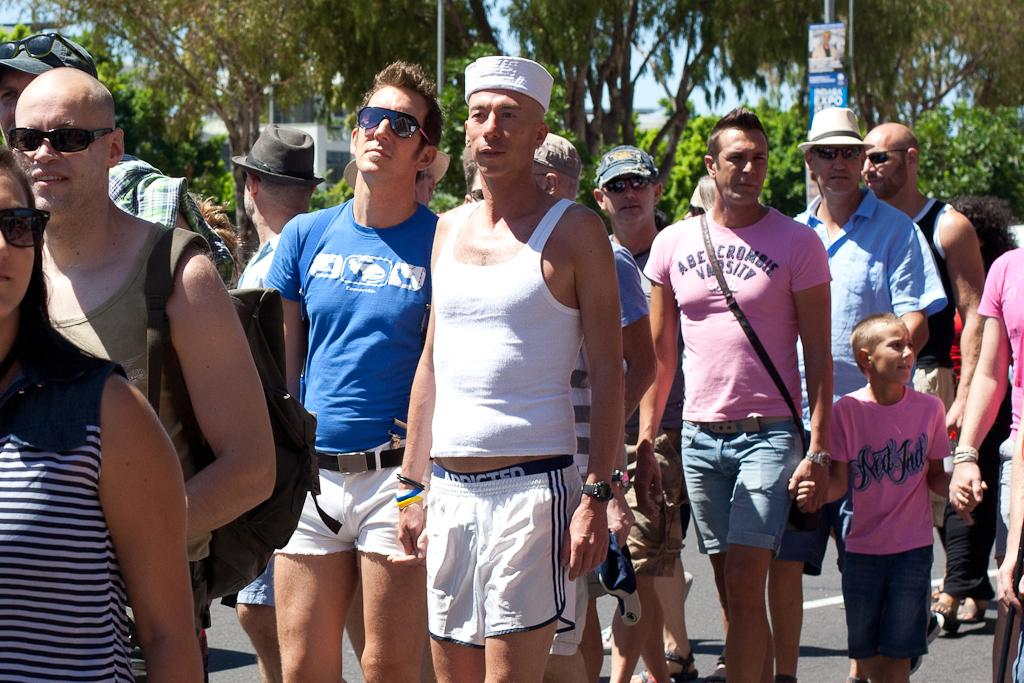Provide a one-sentence caption for the provided image. A man in a pink Abercrombie Varsity shirt holds hands with a little boy in a pink shirt. 